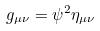Convert formula to latex. <formula><loc_0><loc_0><loc_500><loc_500>g _ { \mu \nu } = \psi ^ { 2 } \eta _ { \mu \nu }</formula> 